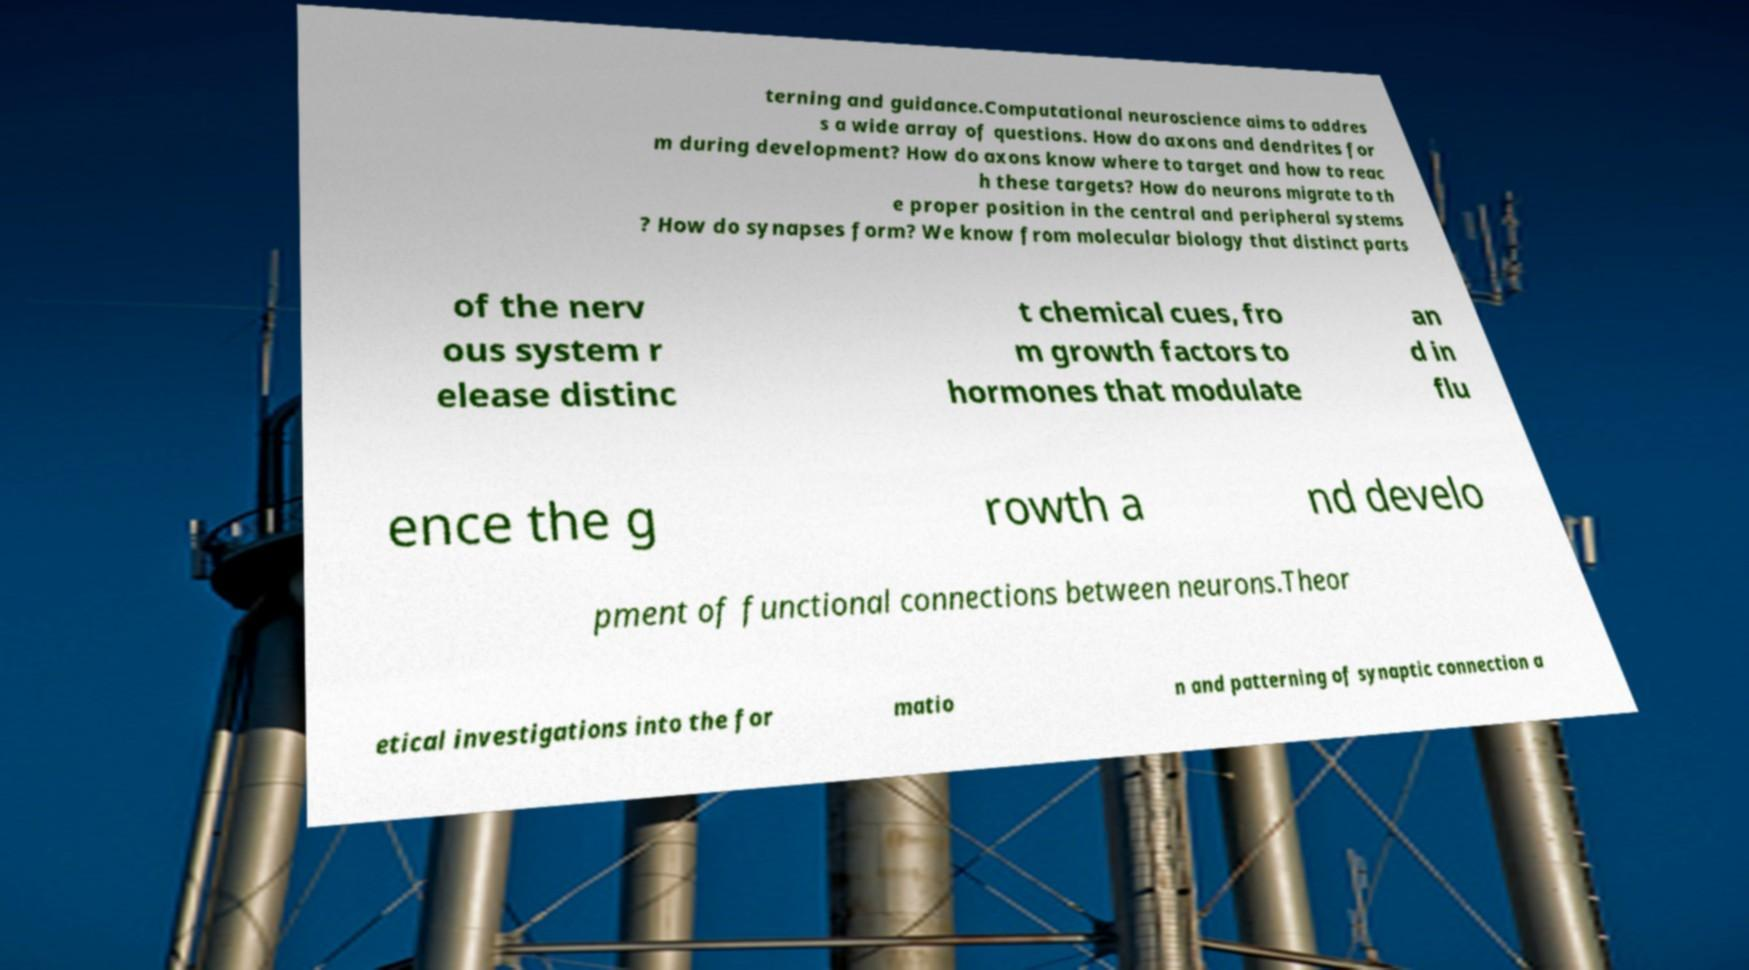What messages or text are displayed in this image? I need them in a readable, typed format. terning and guidance.Computational neuroscience aims to addres s a wide array of questions. How do axons and dendrites for m during development? How do axons know where to target and how to reac h these targets? How do neurons migrate to th e proper position in the central and peripheral systems ? How do synapses form? We know from molecular biology that distinct parts of the nerv ous system r elease distinc t chemical cues, fro m growth factors to hormones that modulate an d in flu ence the g rowth a nd develo pment of functional connections between neurons.Theor etical investigations into the for matio n and patterning of synaptic connection a 